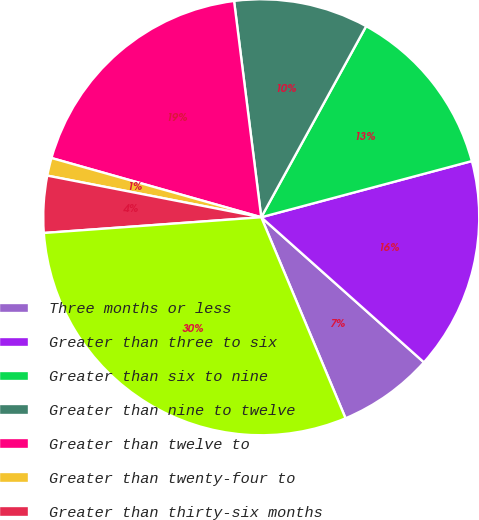Convert chart. <chart><loc_0><loc_0><loc_500><loc_500><pie_chart><fcel>Three months or less<fcel>Greater than three to six<fcel>Greater than six to nine<fcel>Greater than nine to twelve<fcel>Greater than twelve to<fcel>Greater than twenty-four to<fcel>Greater than thirty-six months<fcel>Total fixed maturity<nl><fcel>7.09%<fcel>15.74%<fcel>12.86%<fcel>9.98%<fcel>18.63%<fcel>1.32%<fcel>4.21%<fcel>30.17%<nl></chart> 